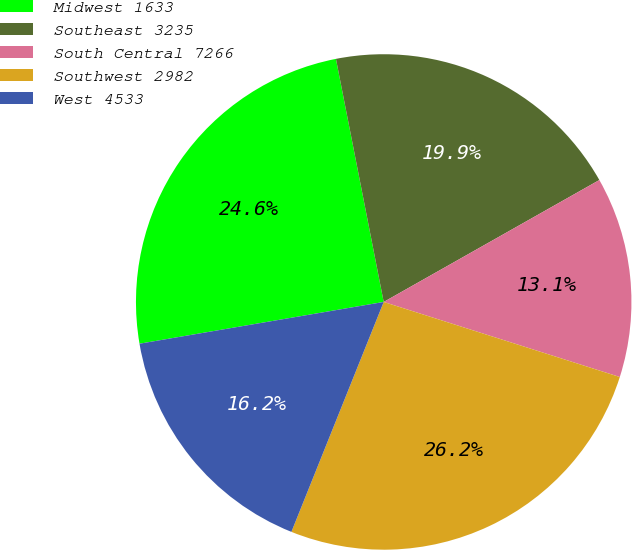Convert chart to OTSL. <chart><loc_0><loc_0><loc_500><loc_500><pie_chart><fcel>Midwest 1633<fcel>Southeast 3235<fcel>South Central 7266<fcel>Southwest 2982<fcel>West 4533<nl><fcel>24.61%<fcel>19.9%<fcel>13.09%<fcel>26.18%<fcel>16.23%<nl></chart> 